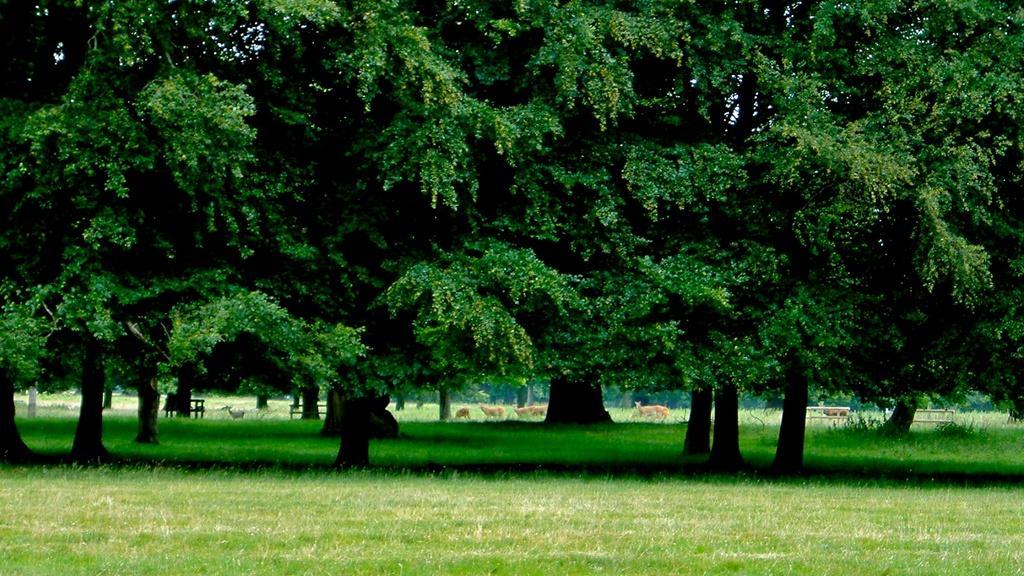Please provide a concise description of this image. In the image we can see there are trees and grass. We can even see there are animals and benches. 